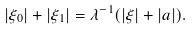<formula> <loc_0><loc_0><loc_500><loc_500>| \xi _ { 0 } | + | \xi _ { 1 } | = \lambda ^ { - 1 } ( | \xi | + | a | ) .</formula> 